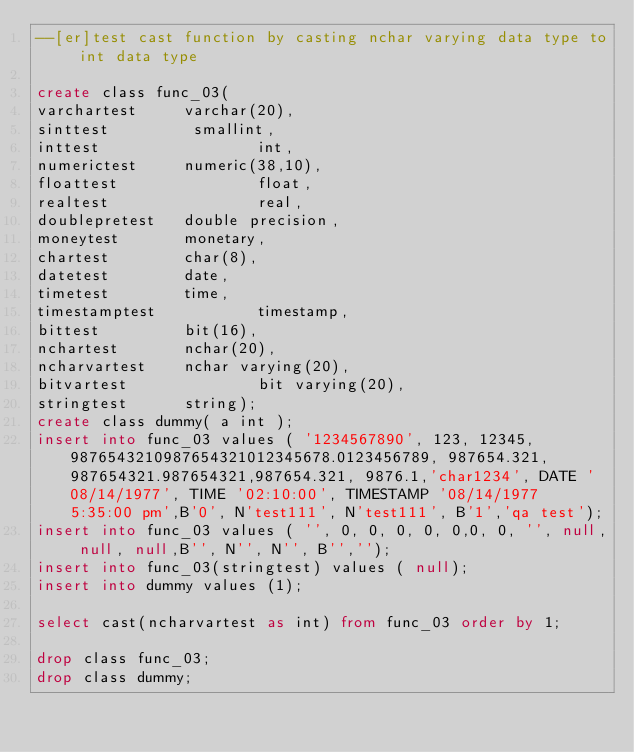<code> <loc_0><loc_0><loc_500><loc_500><_SQL_>--[er]test cast function by casting nchar varying data type to int data type

create class func_03(
varchartest     varchar(20),
sinttest         smallint,
inttest                 int,
numerictest     numeric(38,10),
floattest               float,
realtest                real,
doublepretest   double precision,
moneytest       monetary,
chartest        char(8),
datetest        date,
timetest        time,
timestamptest           timestamp,
bittest         bit(16),
nchartest       nchar(20),
ncharvartest    nchar varying(20),
bitvartest              bit varying(20),
stringtest      string);
create class dummy( a int );
insert into func_03 values ( '1234567890', 123, 12345, 9876543210987654321012345678.0123456789, 987654.321, 987654321.987654321,987654.321, 9876.1,'char1234', DATE '08/14/1977', TIME '02:10:00', TIMESTAMP '08/14/1977 5:35:00 pm',B'0', N'test111', N'test111', B'1','qa test');
insert into func_03 values ( '', 0, 0, 0, 0, 0,0, 0, '', null, null, null,B'', N'', N'', B'','');
insert into func_03(stringtest) values ( null);
insert into dummy values (1);

select cast(ncharvartest as int) from func_03 order by 1;

drop class func_03;
drop class dummy;
</code> 